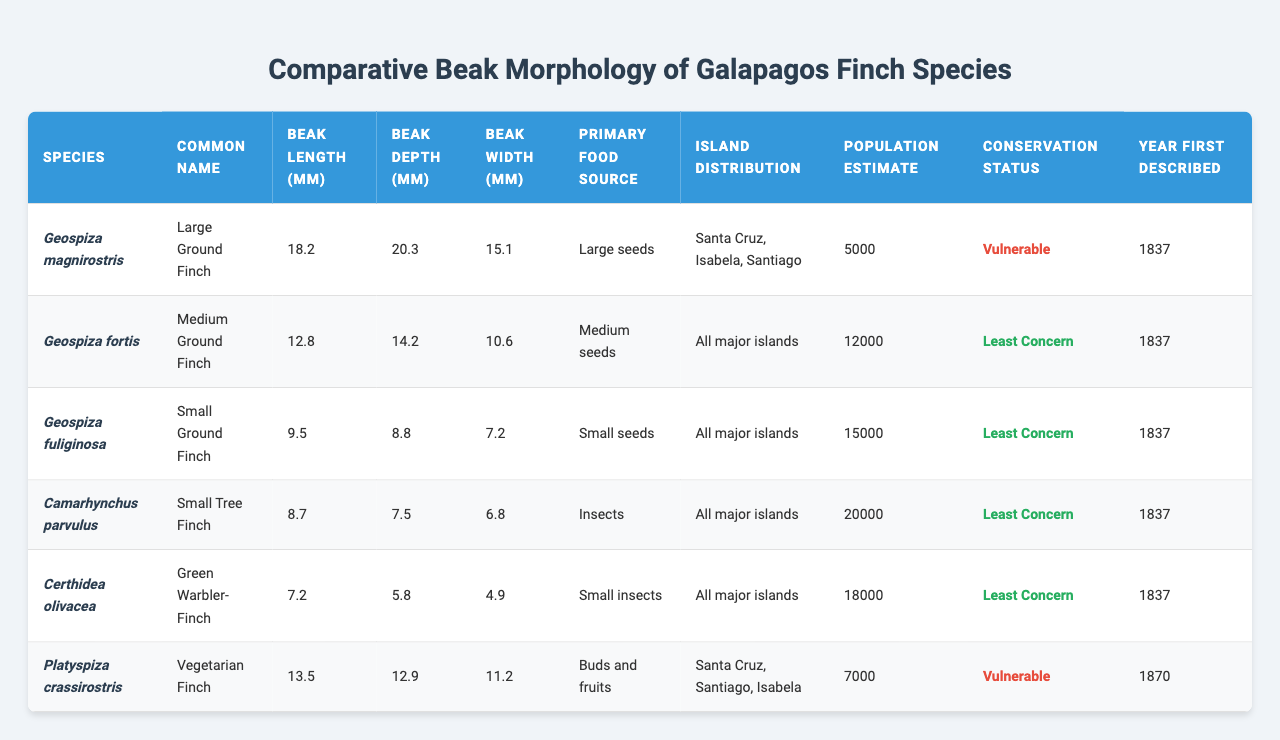What is the beak length of the Large Ground Finch? The beak length for the Large Ground Finch (Geospiza magnirostris) is directly available in the table under the "Beak Length (mm)" column. It shows 18.2 mm.
Answer: 18.2 mm Which species has the smallest beak width? By examining the "Beak Width (mm)" column, the species with the smallest beak width is Certhidea olivacea, which has a width of 4.9 mm.
Answer: Certhidea olivacea What is the total population estimate of all finch species listed in the table? To find the total population estimate, sum the estimates from the "Population Estimate" column: 5000 + 12000 + 15000 + 20000 + 18000 + 7000 = 80000.
Answer: 80000 Which finch has the deepest beak and what is its depth? Referring to the "Beak Depth (mm)" column, the finch with the deepest beak is Geospiza magnirostris with a depth of 20.3 mm.
Answer: Geospiza magnirostris with 20.3 mm What is the average beak length of all the species? To calculate the average beak length, sum the values in the "Beak Length (mm)" column: 18.2 + 12.8 + 9.5 + 8.7 + 7.2 + 13.5 = 69.9 mm. This total is then divided by 6 (the number of species), resulting in an average of 11.65 mm.
Answer: 11.65 mm Is the Green Warbler-Finch classified as vulnerable? By checking the "Conservation Status" column, the Green Warbler-Finch (Certhidea olivacea) is listed as "Least Concern," meaning it is not classified as vulnerable.
Answer: No Which species has the largest beak length and what is its primary food source? The "Beak Length (mm)" column indicates that the largest beak length is 18.2 mm for the Geospiza magnirostris, whose primary food source is large seeds.
Answer: Geospiza magnirostris, large seeds Are all the finch species distributed across all major islands in the Galapagos? By reviewing the "Island Distribution" column, it is evident that not all species are found across all major islands, as the "Large Ground Finch" and "Vegetarian Finch" are found on specific islands only.
Answer: No What food sources do the finches consume, and which species primarily eats insects? Looking at the "Primary Food Source" column, it's clear that the "Small Tree Finch" (Camarhynchus parvulus) and the "Green Warbler-Finch" (Certhidea olivacea) primarily consume insects.
Answer: Camarhynchus parvulus and Certhidea olivacea How many finch species are listed with a conservation status of "Least Concern"? Counting the entries in the "Conservation Status" column marked as "Least Concern," we find four species: Geospiza fortis, Geospiza fuliginosa, Camarhynchus parvulus, and Certhidea olivacea.
Answer: 4 